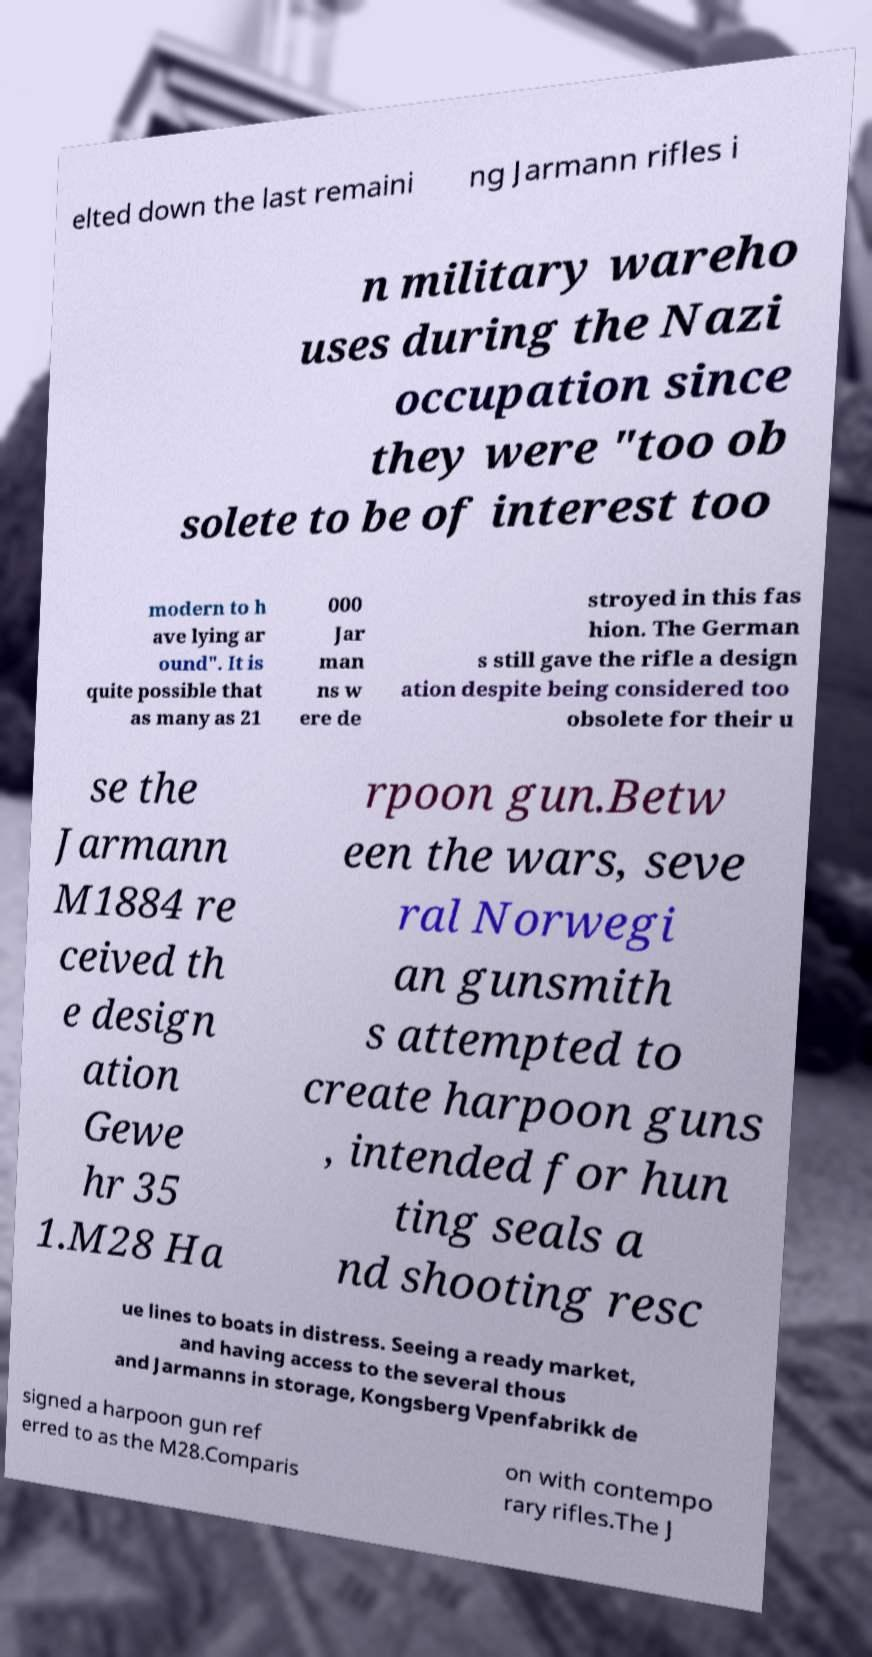Can you accurately transcribe the text from the provided image for me? elted down the last remaini ng Jarmann rifles i n military wareho uses during the Nazi occupation since they were "too ob solete to be of interest too modern to h ave lying ar ound". It is quite possible that as many as 21 000 Jar man ns w ere de stroyed in this fas hion. The German s still gave the rifle a design ation despite being considered too obsolete for their u se the Jarmann M1884 re ceived th e design ation Gewe hr 35 1.M28 Ha rpoon gun.Betw een the wars, seve ral Norwegi an gunsmith s attempted to create harpoon guns , intended for hun ting seals a nd shooting resc ue lines to boats in distress. Seeing a ready market, and having access to the several thous and Jarmanns in storage, Kongsberg Vpenfabrikk de signed a harpoon gun ref erred to as the M28.Comparis on with contempo rary rifles.The J 